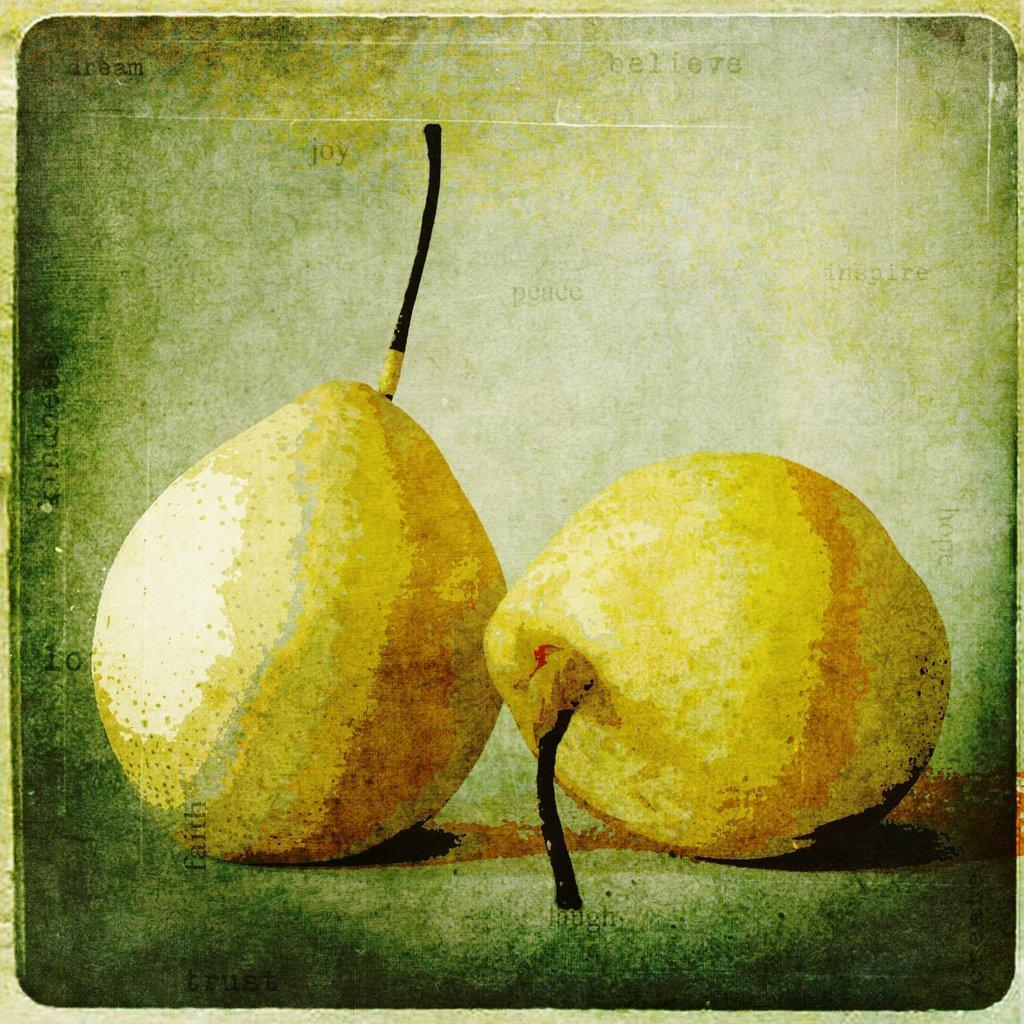What types of objects are present at the bottom of the image? There are two fruits in the image. Can you describe the positioning of the fruits in the image? The fruits are located at the bottom of the image. What type of plantation can be seen in the background of the image? There is no plantation visible in the image; it only features two fruits located at the bottom. 